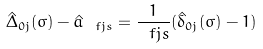Convert formula to latex. <formula><loc_0><loc_0><loc_500><loc_500>\hat { \Delta } _ { 0 j } ( \sigma ) - \hat { a } _ { \ f j s } = \frac { 1 } { \ f j s } ( \hat { \delta } _ { 0 j } ( \sigma ) - 1 )</formula> 